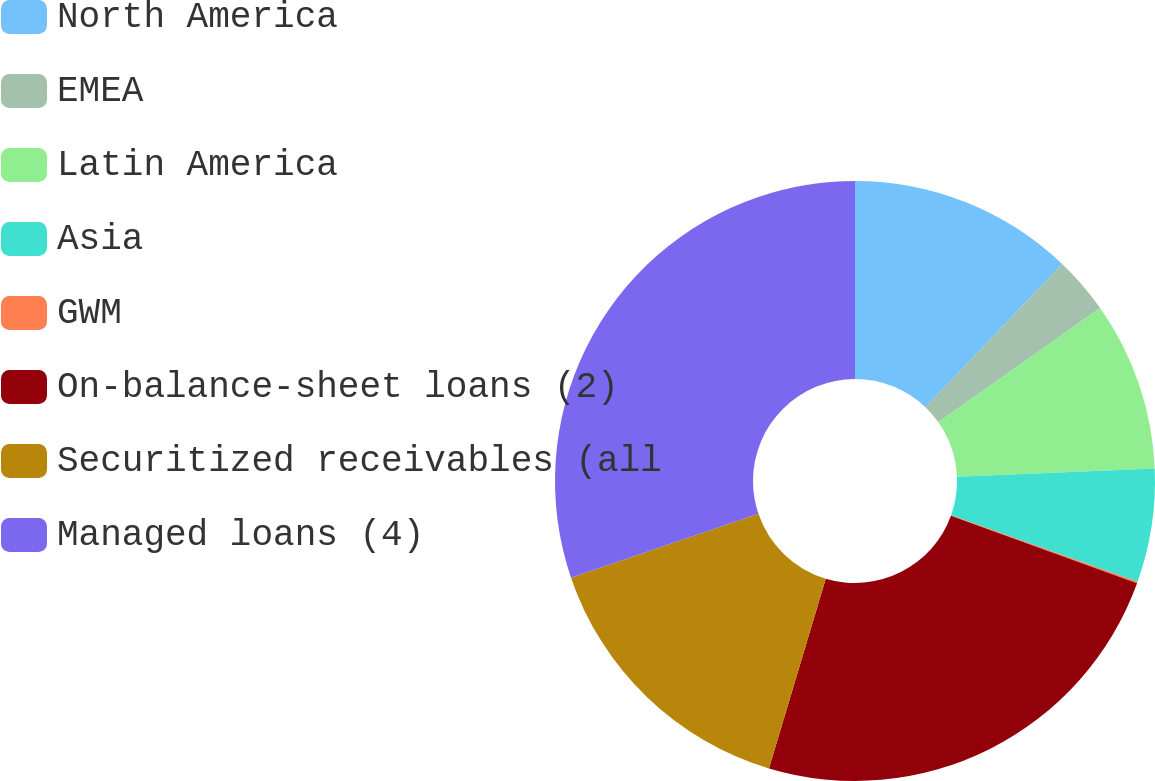Convert chart to OTSL. <chart><loc_0><loc_0><loc_500><loc_500><pie_chart><fcel>North America<fcel>EMEA<fcel>Latin America<fcel>Asia<fcel>GWM<fcel>On-balance-sheet loans (2)<fcel>Securitized receivables (all<fcel>Managed loans (4)<nl><fcel>12.13%<fcel>3.09%<fcel>9.12%<fcel>6.11%<fcel>0.08%<fcel>24.1%<fcel>15.15%<fcel>30.22%<nl></chart> 